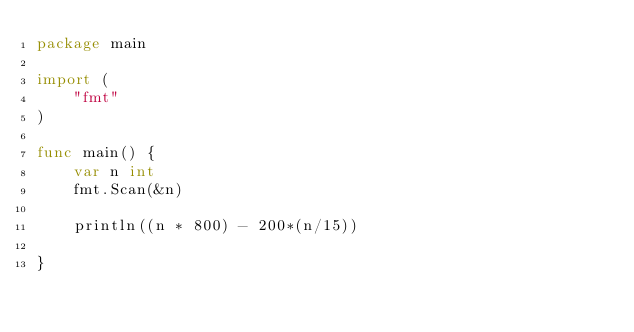<code> <loc_0><loc_0><loc_500><loc_500><_Go_>package main

import (
	"fmt"
)

func main() {
	var n int
	fmt.Scan(&n)

	println((n * 800) - 200*(n/15))

}
</code> 